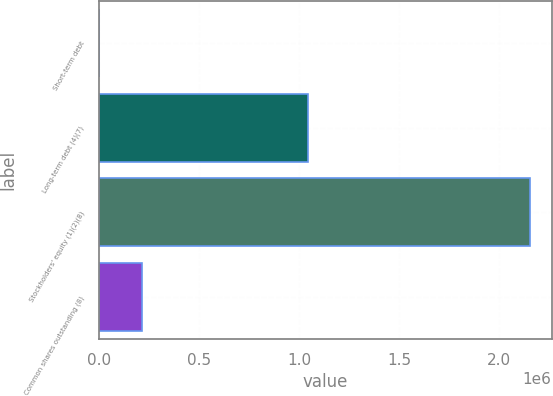<chart> <loc_0><loc_0><loc_500><loc_500><bar_chart><fcel>Short-term debt<fcel>Long-term debt (4)(7)<fcel>Stockholders' equity (1)(2)(8)<fcel>Common shares outstanding (8)<nl><fcel>1172<fcel>1.04525e+06<fcel>2.15357e+06<fcel>216412<nl></chart> 